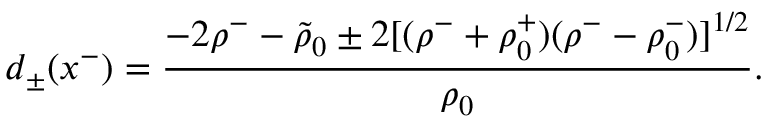Convert formula to latex. <formula><loc_0><loc_0><loc_500><loc_500>d _ { \pm } ( x ^ { - } ) = { \frac { - 2 \rho ^ { - } - \tilde { \rho } _ { 0 } \pm 2 [ ( \rho ^ { - } + \rho _ { 0 } ^ { + } ) ( \rho ^ { - } - \rho _ { 0 } ^ { - } ) ] ^ { 1 / 2 } } { \rho _ { 0 } } } .</formula> 